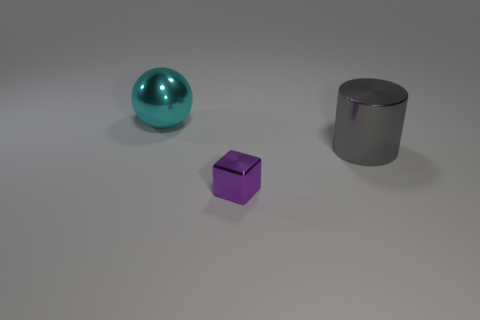Can you describe the colors and shapes of the objects in the image? Certainly! There are three objects: a spherical teal object, a violet cube, and a gray metal cylinder. 